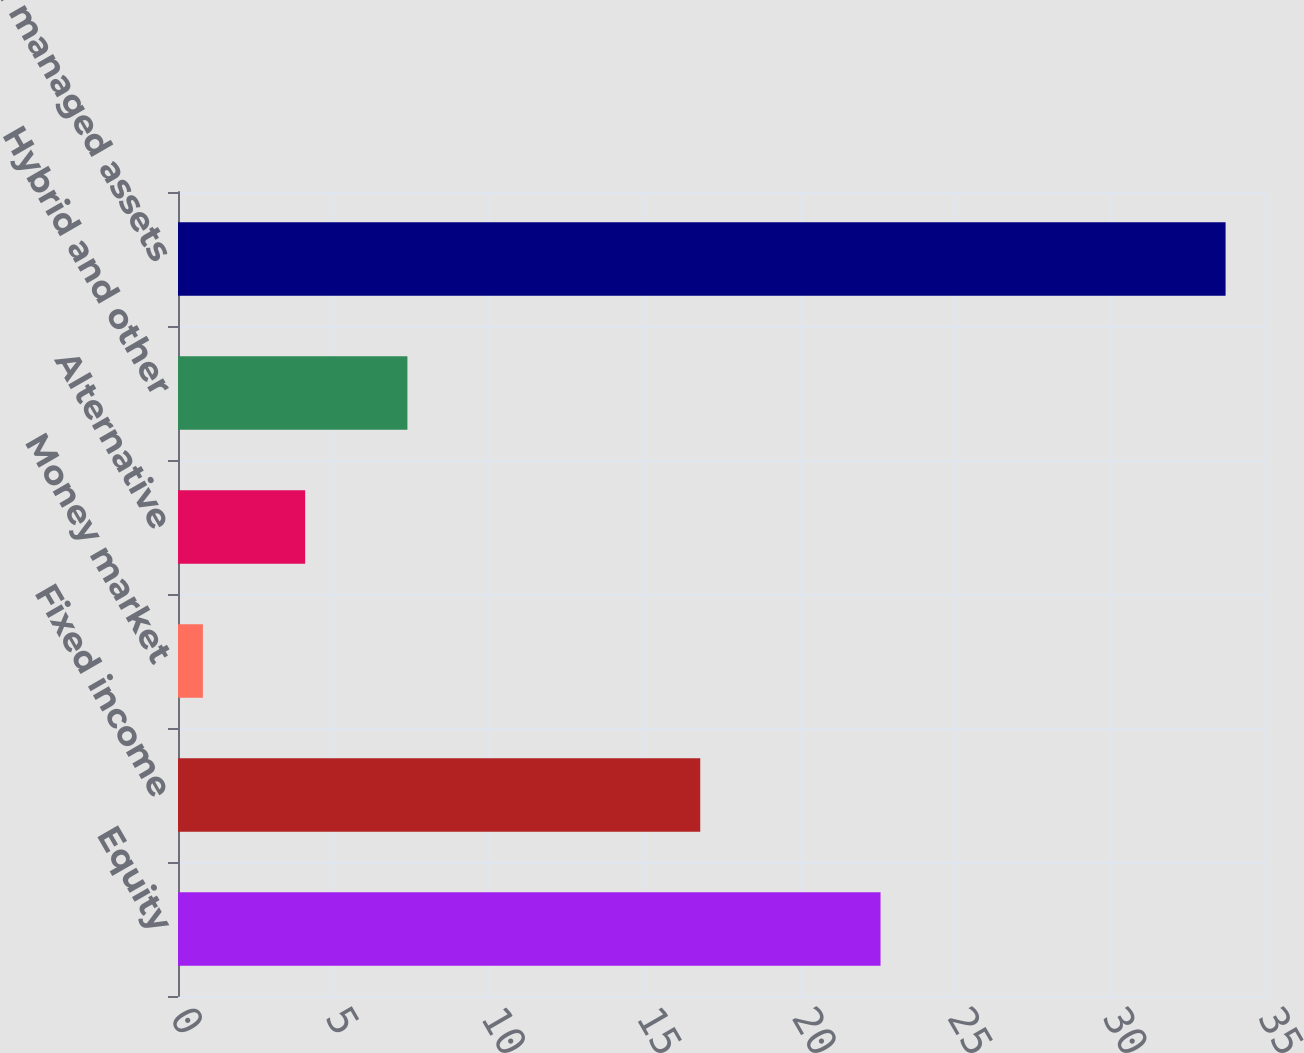<chart> <loc_0><loc_0><loc_500><loc_500><bar_chart><fcel>Equity<fcel>Fixed income<fcel>Money market<fcel>Alternative<fcel>Hybrid and other<fcel>Total managed assets<nl><fcel>22.6<fcel>16.8<fcel>0.8<fcel>4.09<fcel>7.38<fcel>33.7<nl></chart> 